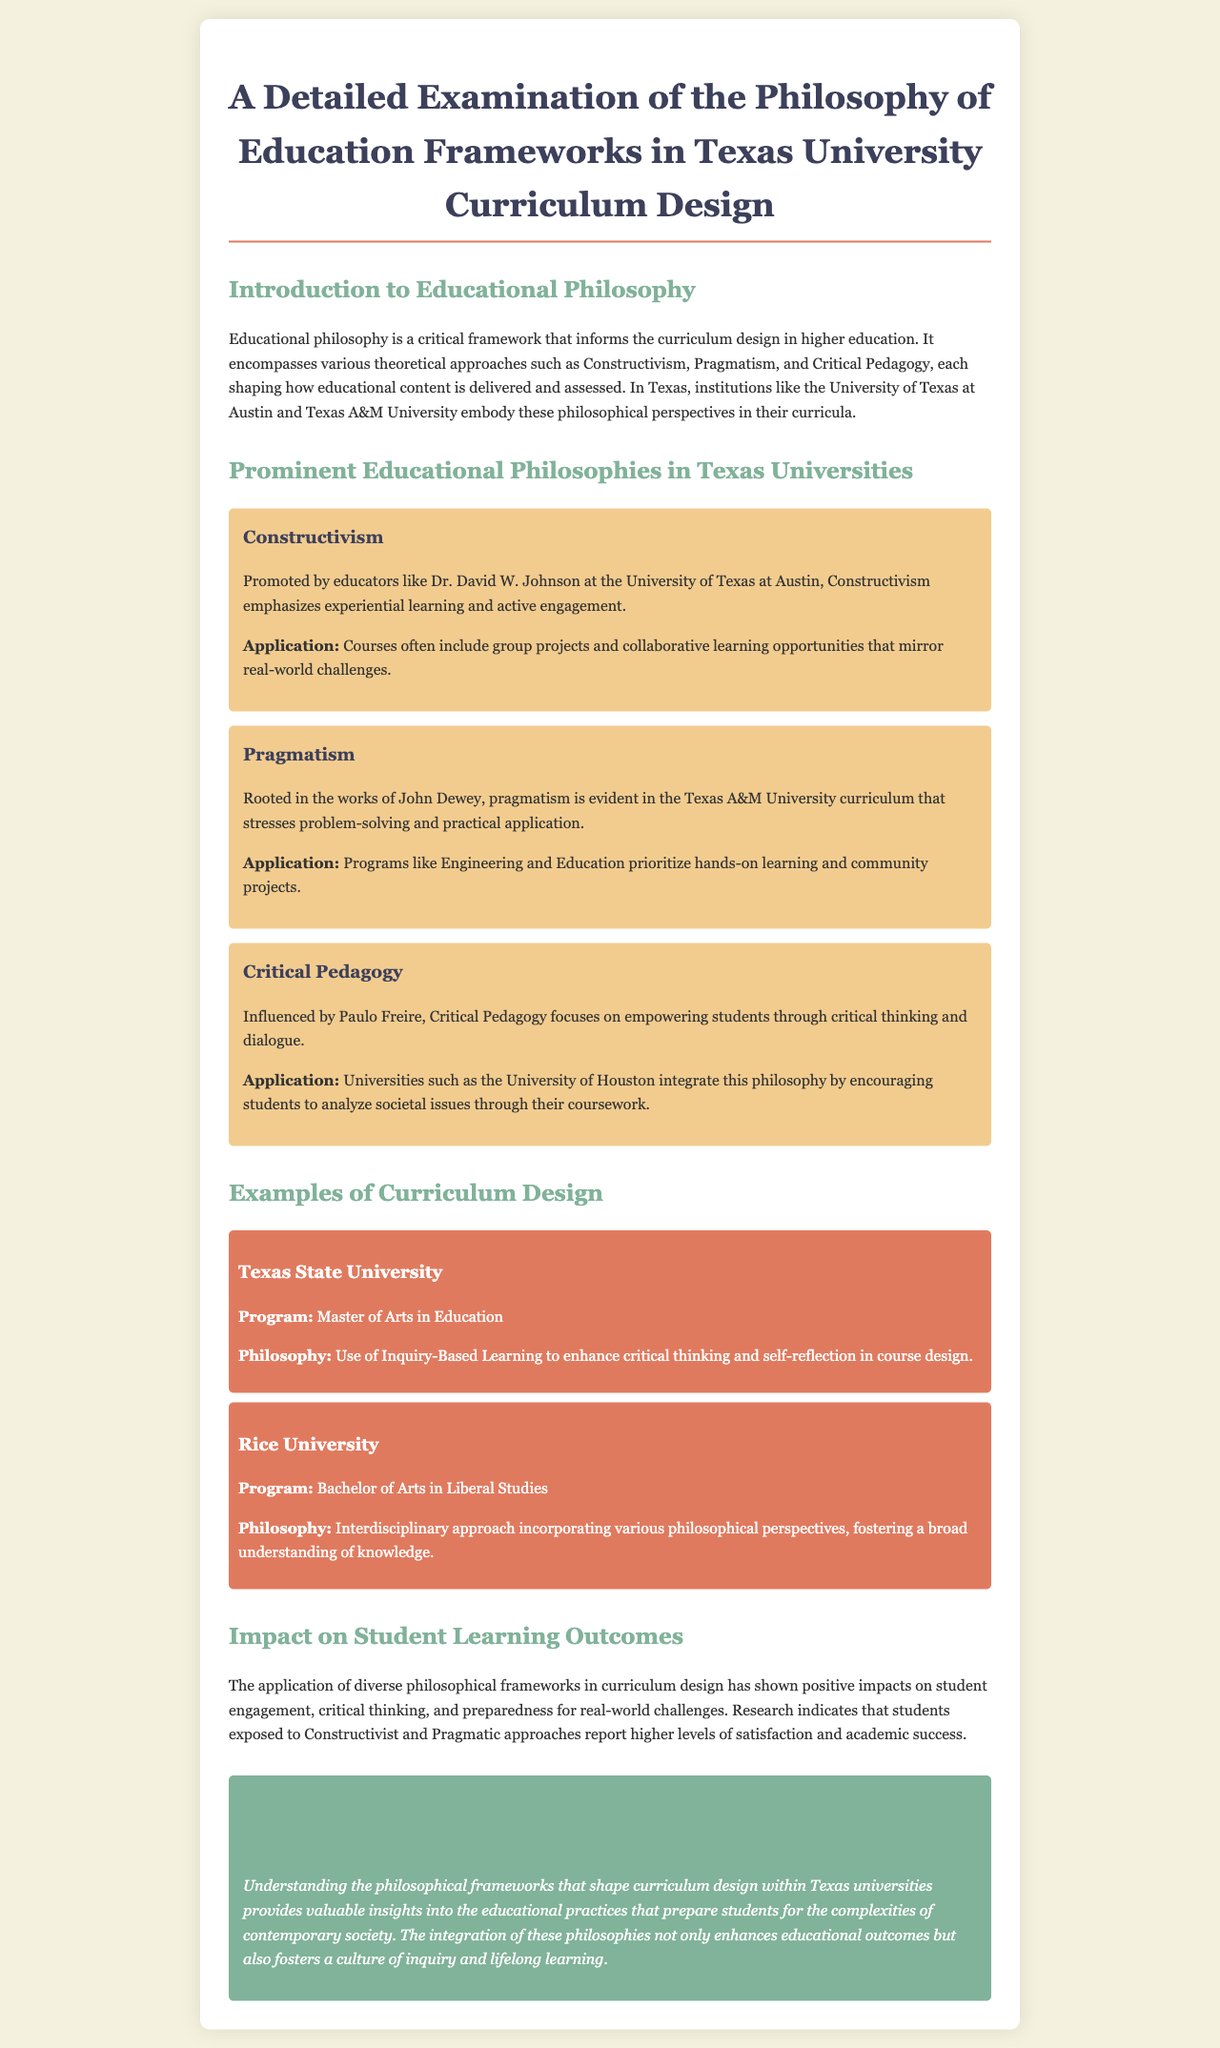What is the title of the report? The title is stated at the top of the document and summarizes the content focused on educational philosophy frameworks in Texas.
Answer: A Detailed Examination of the Philosophy of Education Frameworks in Texas University Curriculum Design Which institution promotes Constructivism? A specific educator and institution are named in relation to Constructivism in the document.
Answer: University of Texas at Austin What educational philosophy is influenced by Paulo Freire? The document lists several educational philosophies, one of which is linked directly to Freire's influence.
Answer: Critical Pedagogy What program is offered at Texas State University? The document provides examples of programs along with their philosophical underpinnings related to specific universities.
Answer: Master of Arts in Education What does the application of philosophical frameworks impact? The document discusses the outcomes of applying these frameworks in curriculum design and their effects on students.
Answer: Student engagement, critical thinking, preparedness Which approach does Rice University incorporate in its curriculum? The document specifies the philosophical approach implemented within a particular program at Rice University.
Answer: Interdisciplinary approach In which philosophy are hands-on learning and community projects prioritized? The document refers to specific applications of educational philosophies, especially one linked to a Texas institution.
Answer: Pragmatism 